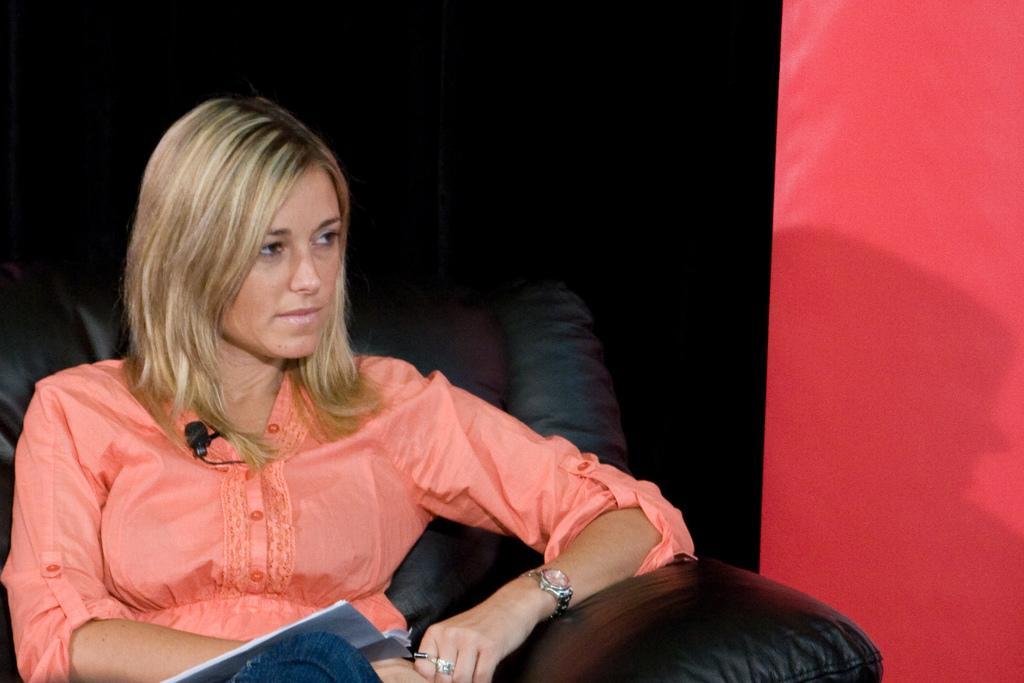Can you describe this image briefly? In this picture, we can see a person with microphone is sitting on a sofa and holding some object, we can see the wall. 